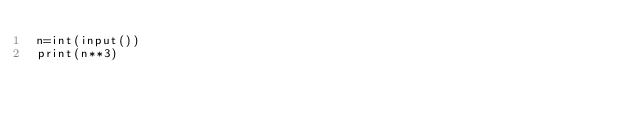Convert code to text. <code><loc_0><loc_0><loc_500><loc_500><_Python_>n=int(input())
print(n**3)</code> 